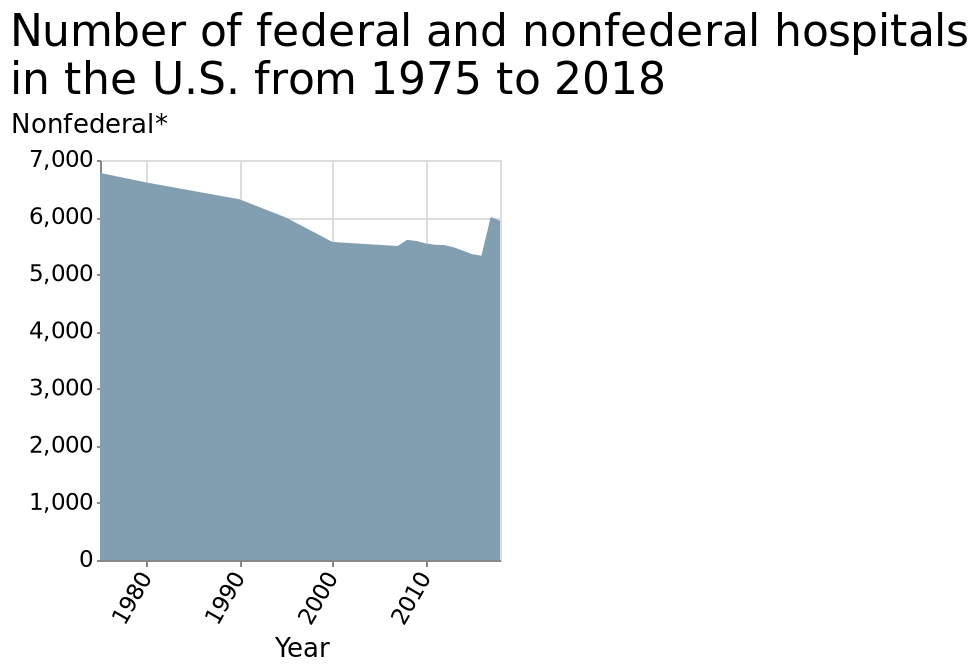<image>
How would you describe the overall trajectory of non federal hospitals based on the chart?  Based on the chart, the overall trend of non federal hospitals is a decline with a recent increase. 